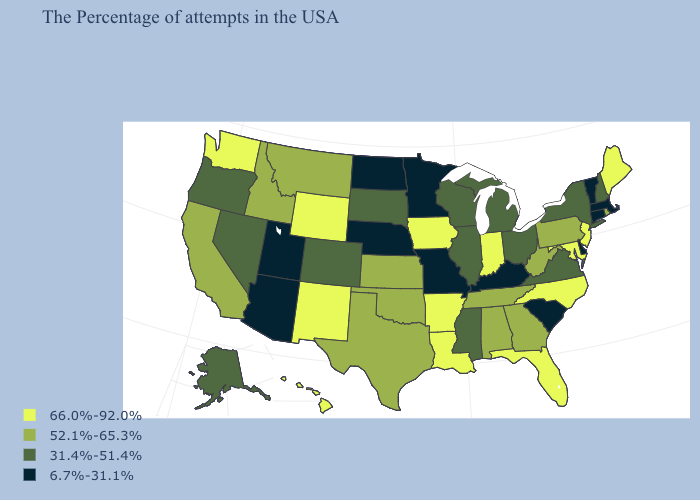What is the value of Colorado?
Concise answer only. 31.4%-51.4%. How many symbols are there in the legend?
Short answer required. 4. Name the states that have a value in the range 31.4%-51.4%?
Answer briefly. New Hampshire, New York, Virginia, Ohio, Michigan, Wisconsin, Illinois, Mississippi, South Dakota, Colorado, Nevada, Oregon, Alaska. Which states hav the highest value in the South?
Concise answer only. Maryland, North Carolina, Florida, Louisiana, Arkansas. What is the value of New Jersey?
Quick response, please. 66.0%-92.0%. What is the highest value in the Northeast ?
Be succinct. 66.0%-92.0%. Among the states that border Mississippi , does Arkansas have the highest value?
Concise answer only. Yes. Which states have the lowest value in the West?
Short answer required. Utah, Arizona. What is the lowest value in the USA?
Give a very brief answer. 6.7%-31.1%. Among the states that border Tennessee , does North Carolina have the highest value?
Quick response, please. Yes. Does Vermont have the same value as Missouri?
Be succinct. Yes. What is the value of New Hampshire?
Concise answer only. 31.4%-51.4%. Does North Dakota have the highest value in the USA?
Give a very brief answer. No. Does Rhode Island have the lowest value in the USA?
Concise answer only. No. Name the states that have a value in the range 31.4%-51.4%?
Concise answer only. New Hampshire, New York, Virginia, Ohio, Michigan, Wisconsin, Illinois, Mississippi, South Dakota, Colorado, Nevada, Oregon, Alaska. 